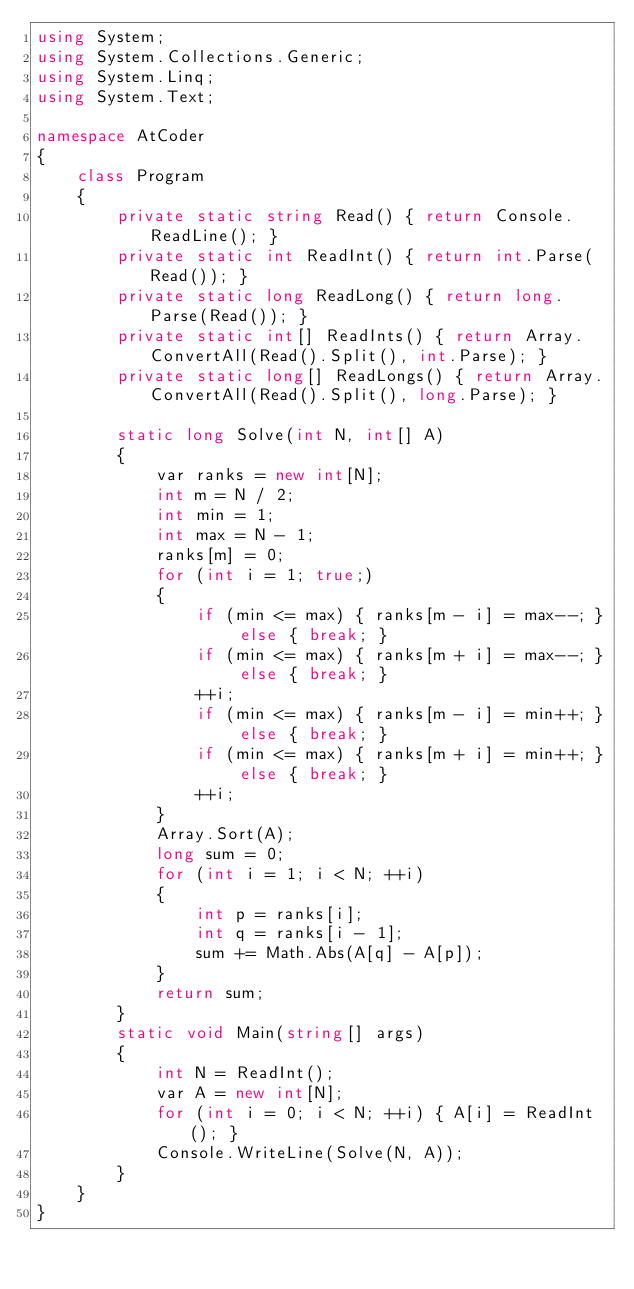<code> <loc_0><loc_0><loc_500><loc_500><_C#_>using System;
using System.Collections.Generic;
using System.Linq;
using System.Text;

namespace AtCoder
{
    class Program
    {
        private static string Read() { return Console.ReadLine(); }
        private static int ReadInt() { return int.Parse(Read()); }
        private static long ReadLong() { return long.Parse(Read()); }
        private static int[] ReadInts() { return Array.ConvertAll(Read().Split(), int.Parse); }
        private static long[] ReadLongs() { return Array.ConvertAll(Read().Split(), long.Parse); }

        static long Solve(int N, int[] A)
        {
            var ranks = new int[N];
            int m = N / 2;
            int min = 1;
            int max = N - 1;
            ranks[m] = 0;
            for (int i = 1; true;)
            {
                if (min <= max) { ranks[m - i] = max--; } else { break; }
                if (min <= max) { ranks[m + i] = max--; } else { break; }
                ++i;
                if (min <= max) { ranks[m - i] = min++; } else { break; }
                if (min <= max) { ranks[m + i] = min++; } else { break; }
                ++i;
            }
            Array.Sort(A);
            long sum = 0;
            for (int i = 1; i < N; ++i)
            {
                int p = ranks[i];
                int q = ranks[i - 1];
                sum += Math.Abs(A[q] - A[p]);
            }
            return sum;
        }
        static void Main(string[] args)
        {
            int N = ReadInt();
            var A = new int[N];
            for (int i = 0; i < N; ++i) { A[i] = ReadInt(); }
            Console.WriteLine(Solve(N, A));
        }
    }
}</code> 